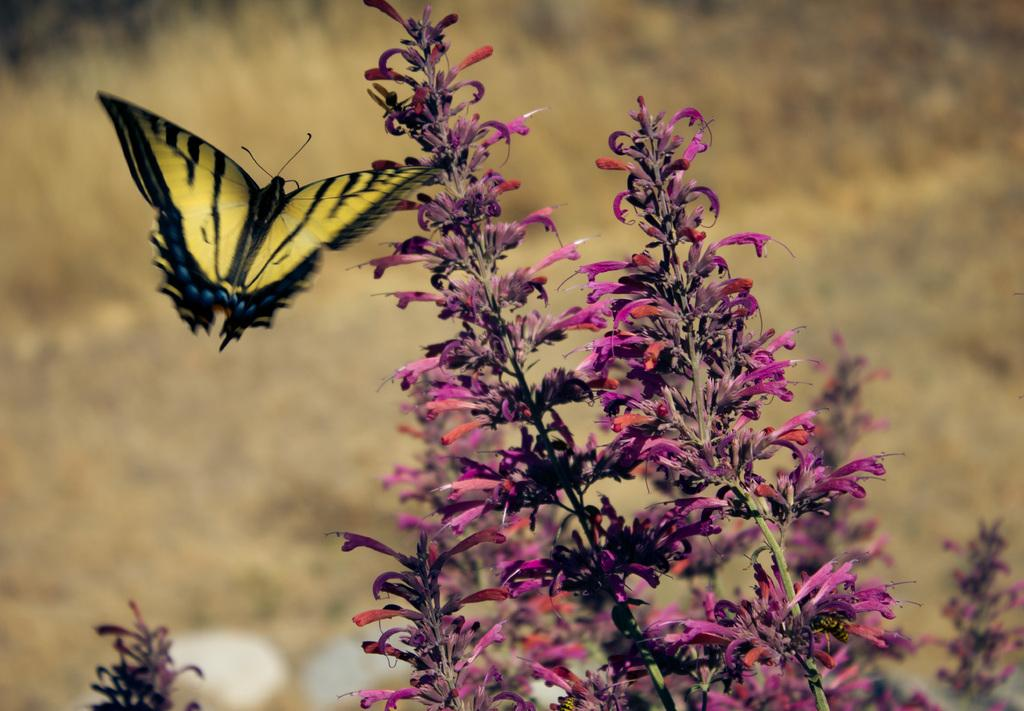What type of insect is present in the image? There is a yellow color butterfly in the picture. What can be seen on the right side of the picture? There is a plant on the right side of the picture. What are the characteristics of the plant? The plant has flowers and buds. What type of vegetation is visible in the background of the picture? There is grass in the background of the picture. What type of instrument is being played by the butterfly in the image? There is no instrument being played in the image, as it features a butterfly and a plant. How many frogs are visible in the image? There are no frogs present in the image. 